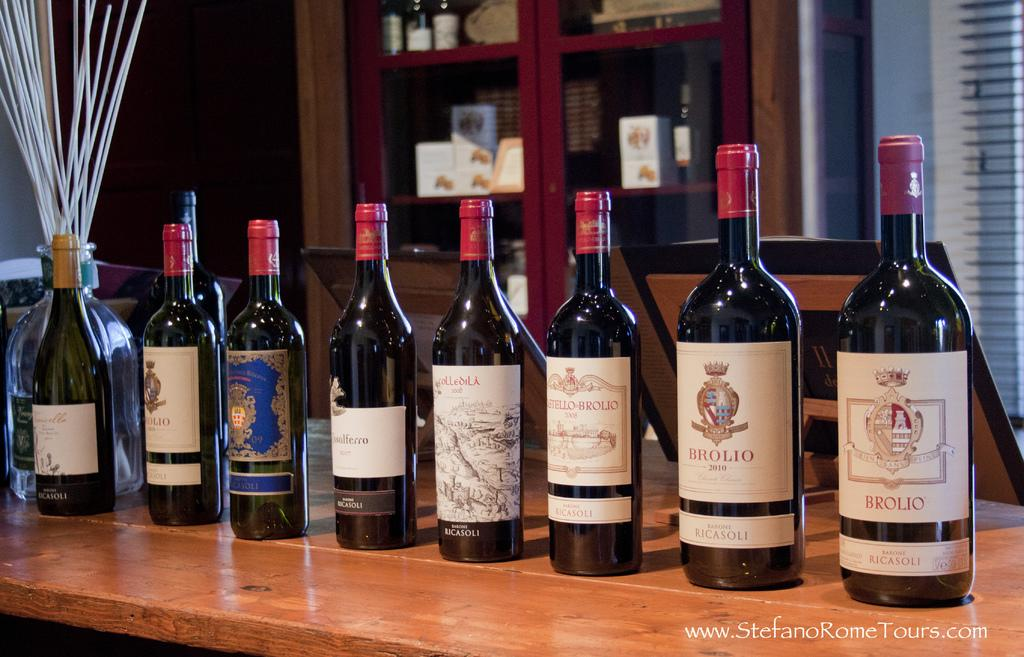Provide a one-sentence caption for the provided image. A bottle of Brolio red wine stands on display with several other bottles of wine. 